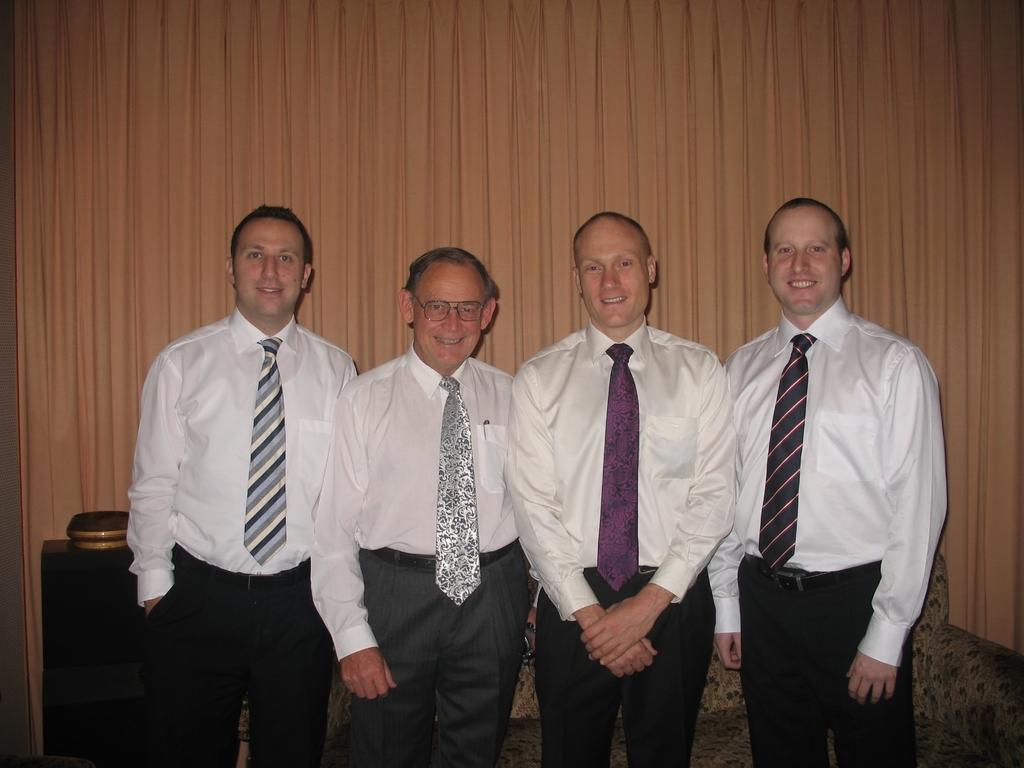Please provide a concise description of this image. In this image we can see four people standing. They are all wearing ties. In the background there is a curtain. At the bottom we can see a sofa and a stand. 